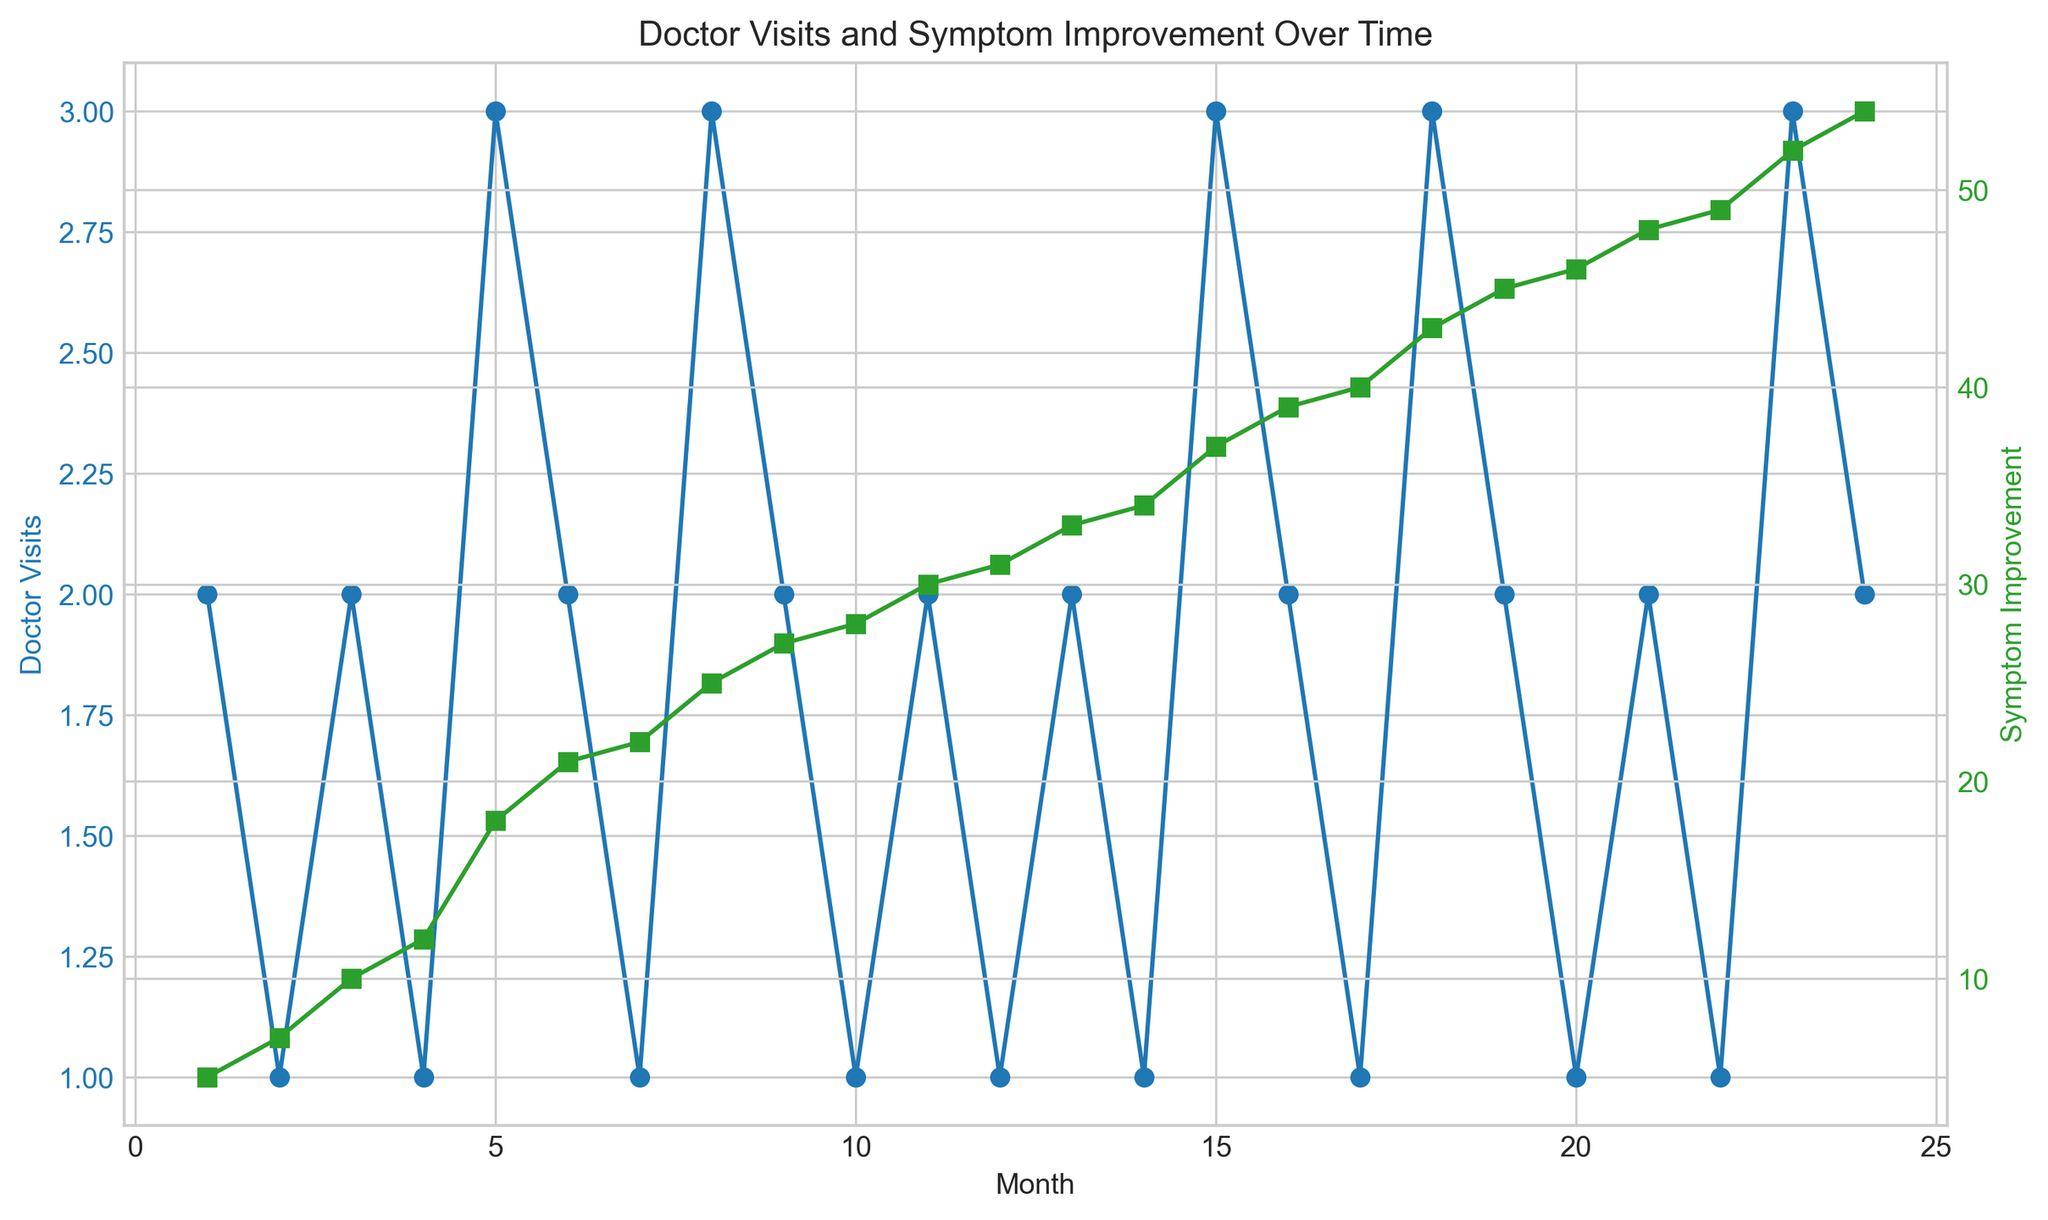What are the doctor visit trends over the first 6 months? In the first 6 months, we see that the doctor visits are somewhat sporadic, fluctuating between 1 and 3 visits per month. Specifically, Month 1 had 2 visits, Month 2 had 1 visit, Month 3 had 2 visits, Month 4 had 1 visit, Month 5 had 3 visits, and Month 6 had 2 visits.
Answer: Fluctuating between 1 and 3 visits Is there a month where both doctor visits and symptom improvement peaked together? By observing the plot, we can see that in Month 5, both doctor visits (3 visits) and symptom improvement (18) reached relatively high values simultaneously. Although not the absolute peak of symptom improvement, it is a noticeable high point for both metrics during the same month.
Answer: Month 5 Which month showed the greatest increase in symptom improvement compared to the previous month? To find the greatest increase, we need to compare symptom improvements month over month. The largest increase is between Month 5 (18) and Month 6 (21), with a difference of 3.
Answer: Month 5 to Month 6 How does the frequency of doctor visits correlate with symptom improvement from Month 1 to Month 24? The general trend is that with an increase in the number of doctor visits, there is usually an increase in symptom improvement. This correlation can be seen clearly whenever spikes in doctor visits coincide with noticeable jumps in symptom improvement, though there are some months with fewer visits that still show improvement.
Answer: Positive correlation What are the respective values for doctor visits and symptom improvement in the 12th month? By checking Month 12 on the plot, we can see that there was 1 doctor visit and a symptom improvement score of 31.
Answer: 1 visit, symptom improvement of 31 On which months did doctor visits drop to the lowest value? Lowest possible value is 1 visit. From the plot, this happened in several months: Month 2, Month 4, Month 7, Month 10, Month 14, Month 17, Month 20, and Month 22.
Answer: Months 2, 4, 7, 10, 14, 17, 20, and 22 Compare the symptoms improvement between Month 3 and Month 6. From the figure, symptom improvement in Month 3 is 10, and in Month 6 is 21. The improvement is greater in Month 6.
Answer: Month 6 has greater improvement What is the color of the line representing symptom improvement? The plot uses two colors to distinguish between doctor visits and symptom improvement. The line that indicates symptom improvement is colored green.
Answer: Green What is the average increase in symptom improvement per month over the whole period (Months 1-24)? To calculate the average increase, sum the total increase in symptom improvement over the months and divide by the number of months. The total improvement from Month 1 to Month 24 is (54 - 5) = 49. Dividing this by 23 (since the first month has no improvement to compare against), the average monthly increase is about 2.13.
Answer: Approximately 2.13 